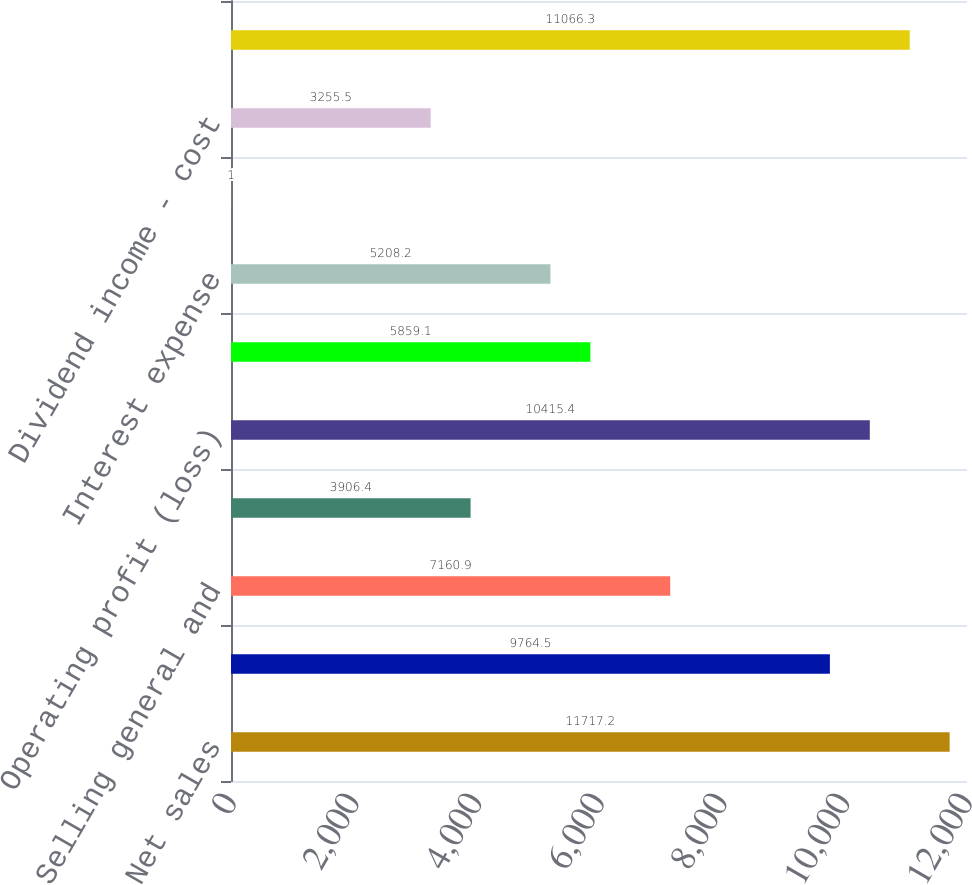Convert chart to OTSL. <chart><loc_0><loc_0><loc_500><loc_500><bar_chart><fcel>Net sales<fcel>Gross profit<fcel>Selling general and<fcel>Other (charges) gains net<fcel>Operating profit (loss)<fcel>Equity in net earnings of<fcel>Interest expense<fcel>Refinancing expense<fcel>Dividend income - cost<fcel>Earnings (loss) from<nl><fcel>11717.2<fcel>9764.5<fcel>7160.9<fcel>3906.4<fcel>10415.4<fcel>5859.1<fcel>5208.2<fcel>1<fcel>3255.5<fcel>11066.3<nl></chart> 